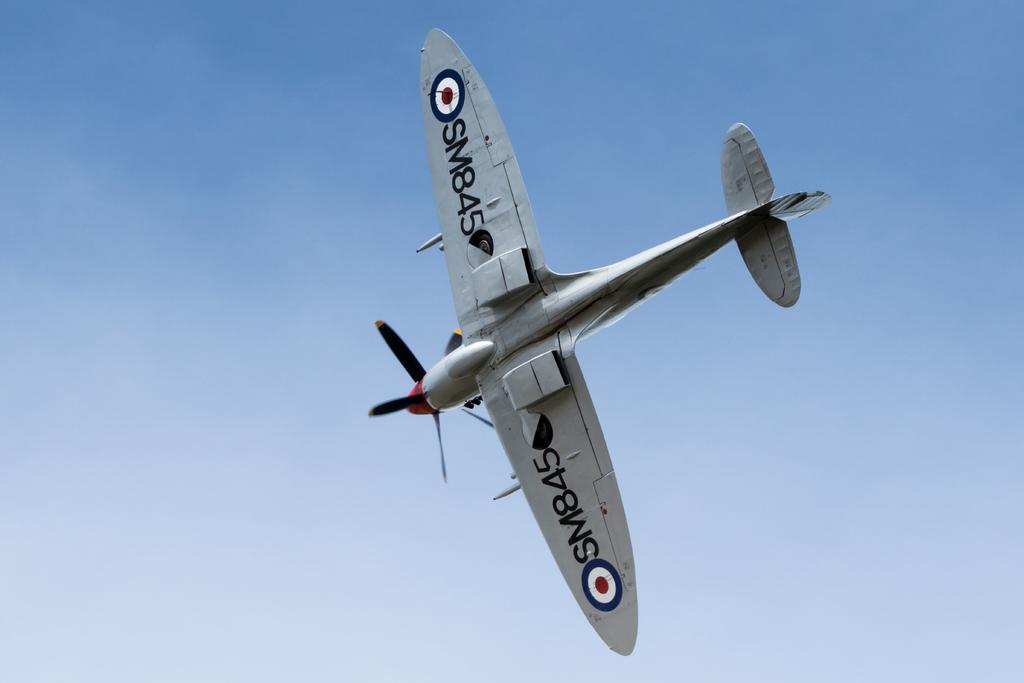Provide a one-sentence caption for the provided image. The British propeller plane SM845 flies in the blue sky. 